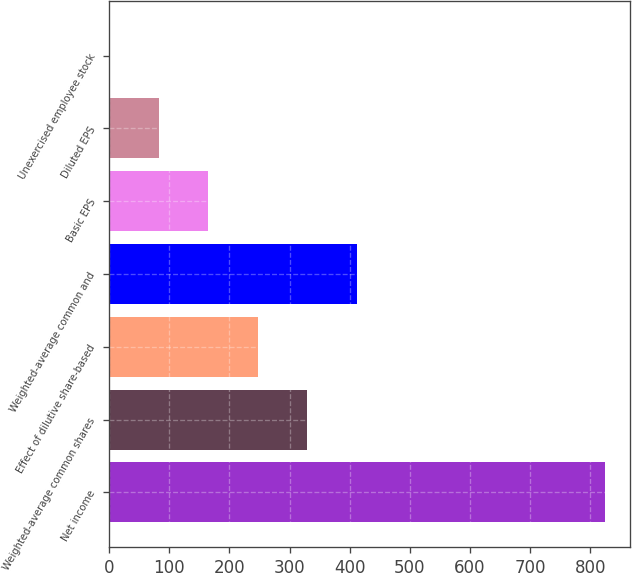Convert chart to OTSL. <chart><loc_0><loc_0><loc_500><loc_500><bar_chart><fcel>Net income<fcel>Weighted-average common shares<fcel>Effect of dilutive share-based<fcel>Weighted-average common and<fcel>Basic EPS<fcel>Diluted EPS<fcel>Unexercised employee stock<nl><fcel>824<fcel>329.66<fcel>247.27<fcel>412.05<fcel>164.88<fcel>82.49<fcel>0.1<nl></chart> 